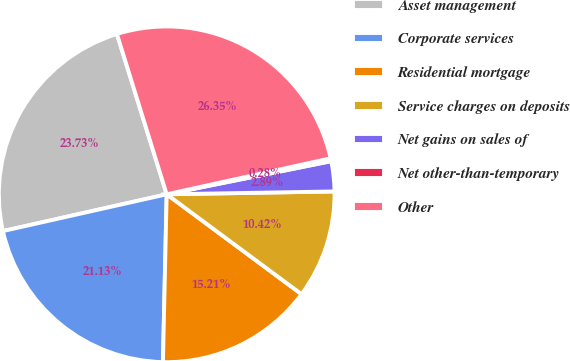Convert chart to OTSL. <chart><loc_0><loc_0><loc_500><loc_500><pie_chart><fcel>Asset management<fcel>Corporate services<fcel>Residential mortgage<fcel>Service charges on deposits<fcel>Net gains on sales of<fcel>Net other-than-temporary<fcel>Other<nl><fcel>23.73%<fcel>21.13%<fcel>15.21%<fcel>10.42%<fcel>2.89%<fcel>0.28%<fcel>26.35%<nl></chart> 